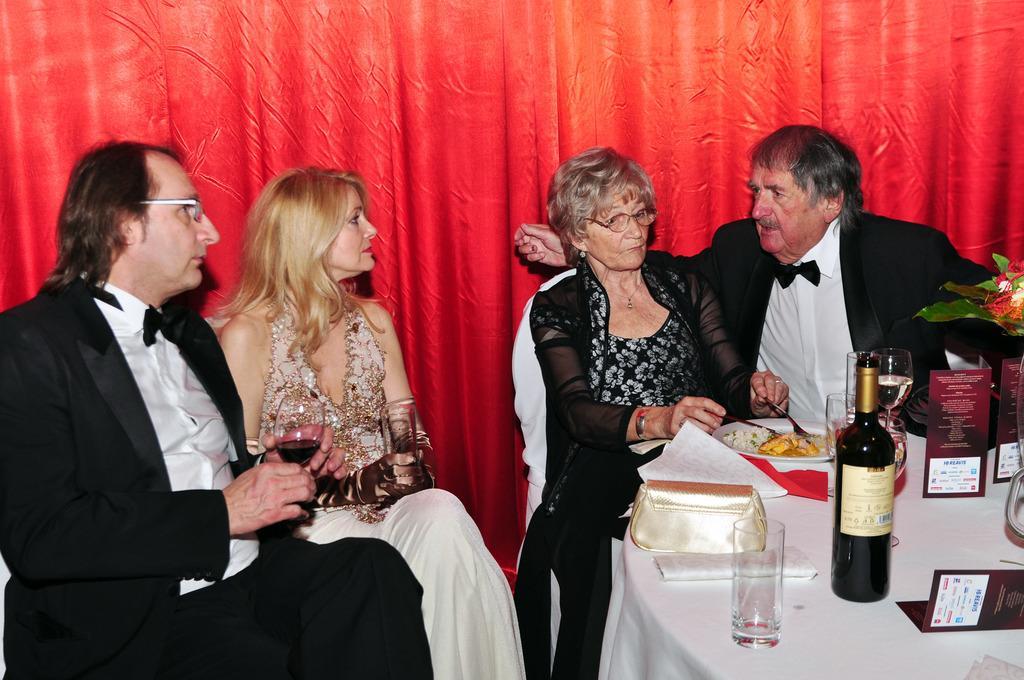Could you give a brief overview of what you see in this image? In this picture we can see two men and two women sitting on chairs and in front of them on the table we can see glasses, bottle, plate with food in it, cards, purse and in the background we can see a red curtain. 